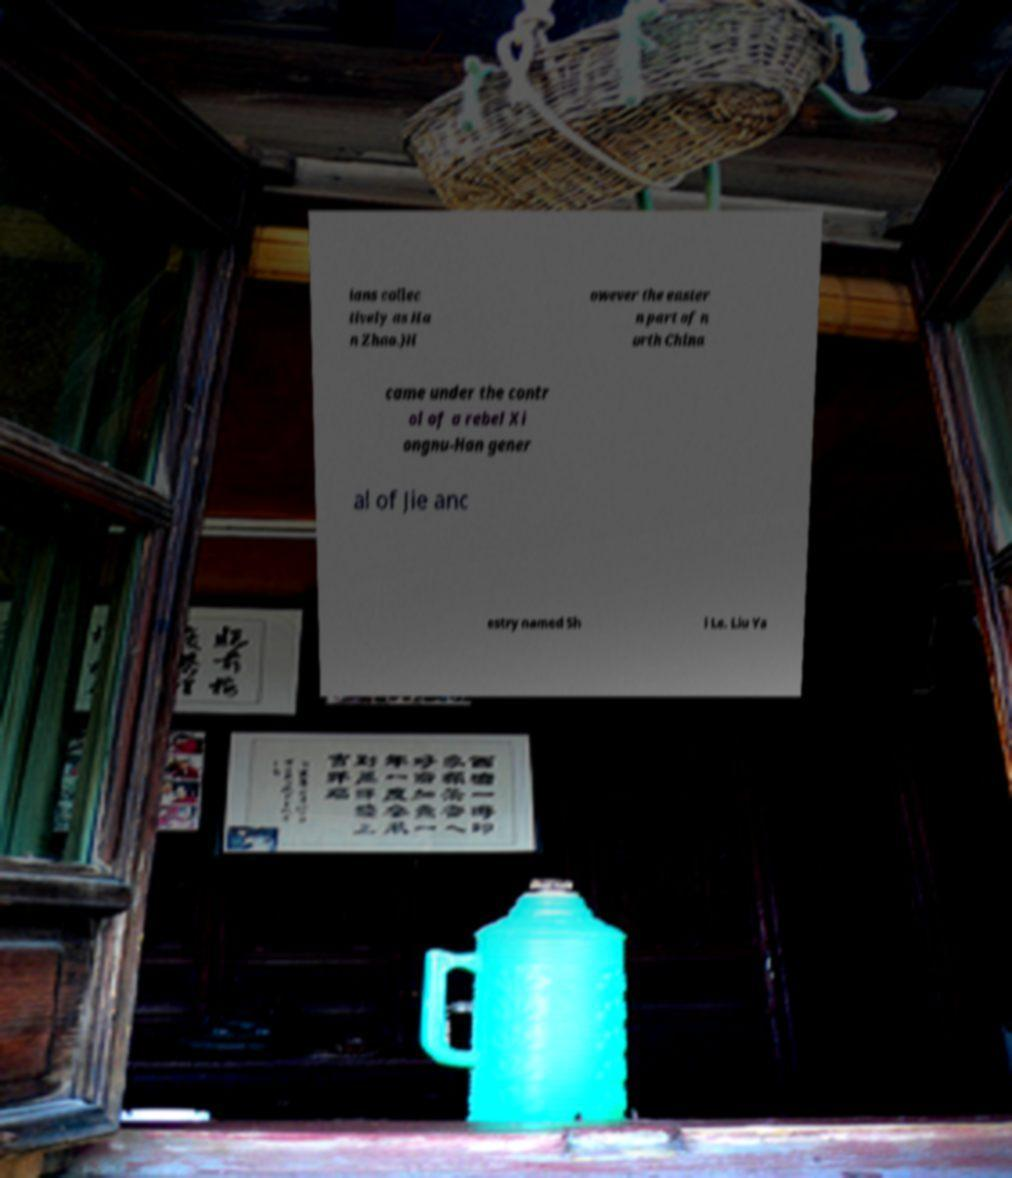Could you assist in decoding the text presented in this image and type it out clearly? ians collec tively as Ha n Zhao.)H owever the easter n part of n orth China came under the contr ol of a rebel Xi ongnu-Han gener al of Jie anc estry named Sh i Le. Liu Ya 